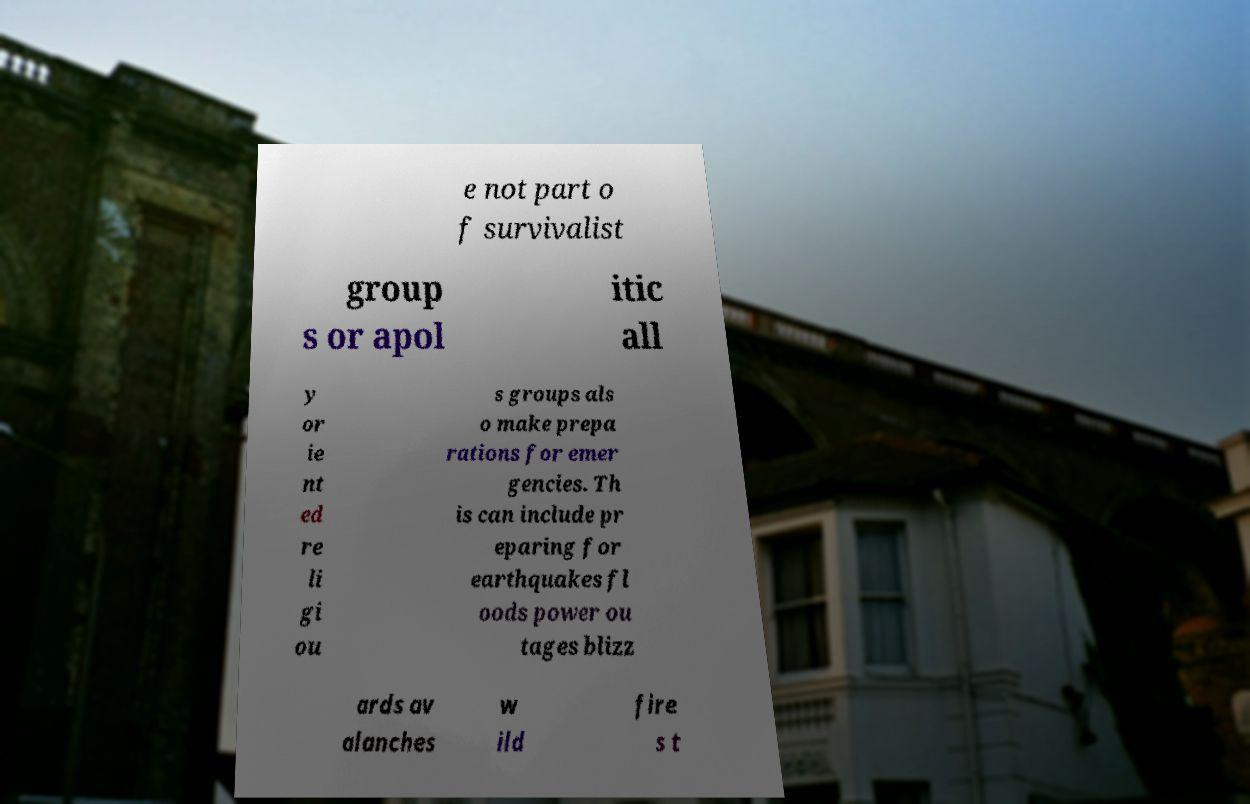There's text embedded in this image that I need extracted. Can you transcribe it verbatim? e not part o f survivalist group s or apol itic all y or ie nt ed re li gi ou s groups als o make prepa rations for emer gencies. Th is can include pr eparing for earthquakes fl oods power ou tages blizz ards av alanches w ild fire s t 